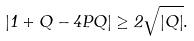<formula> <loc_0><loc_0><loc_500><loc_500>| 1 + Q - 4 P Q | \geq 2 \sqrt { | Q | } .</formula> 